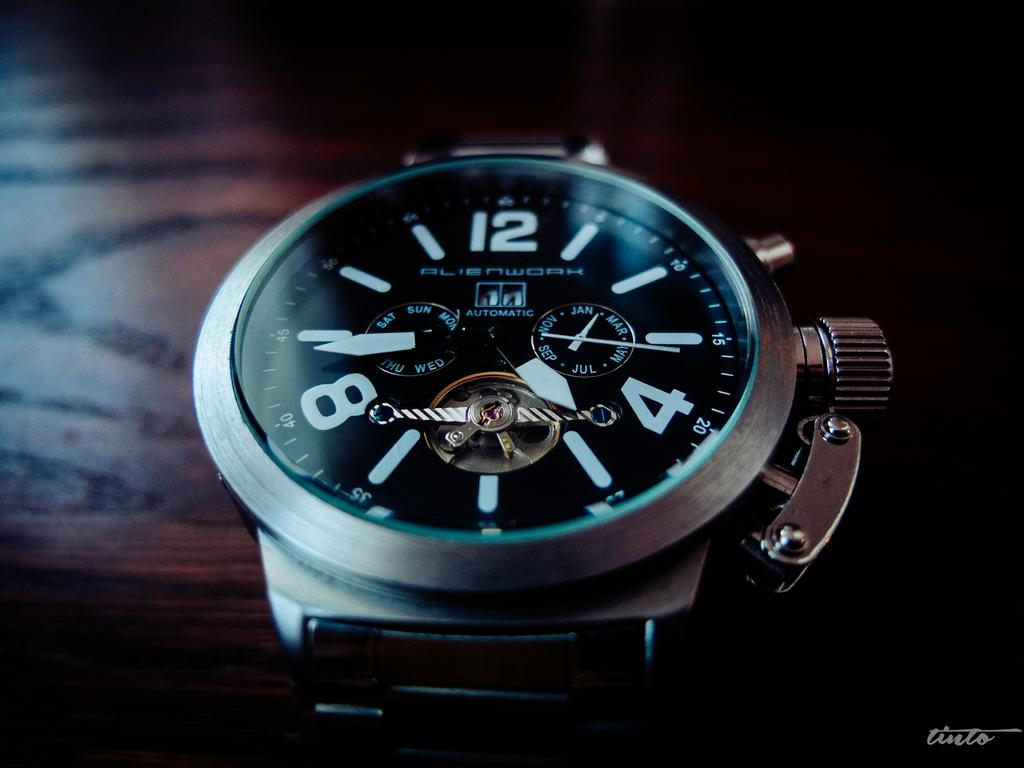<image>
Present a compact description of the photo's key features. Face of a watch which says Alienwork on the screen. 